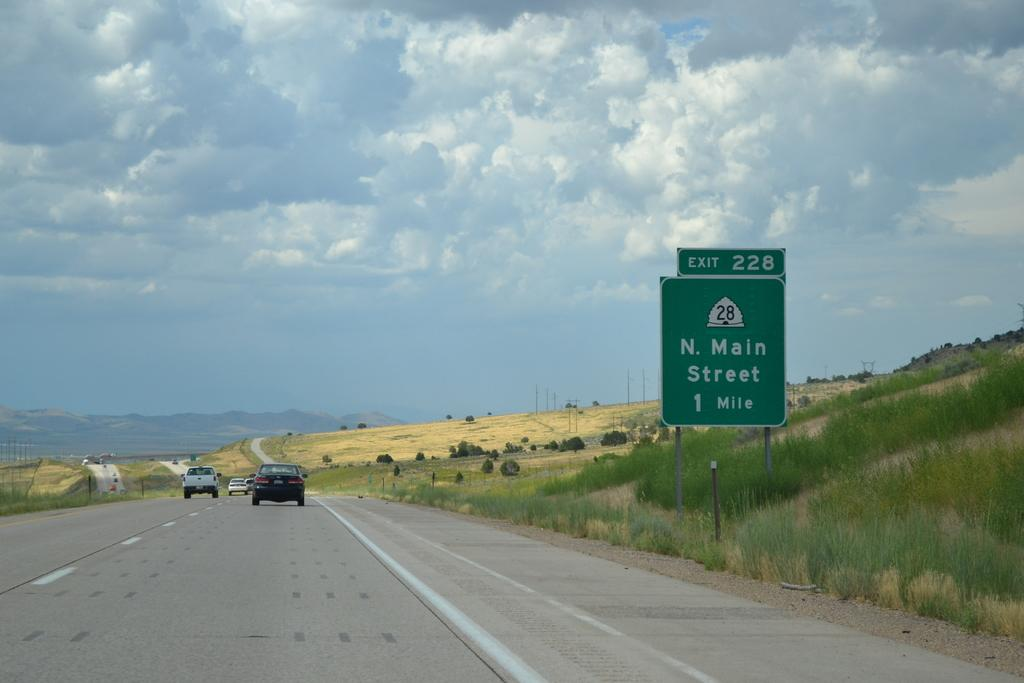<image>
Render a clear and concise summary of the photo. A street sign informs drivers passing by that the North Main Street exit is in one mile. 